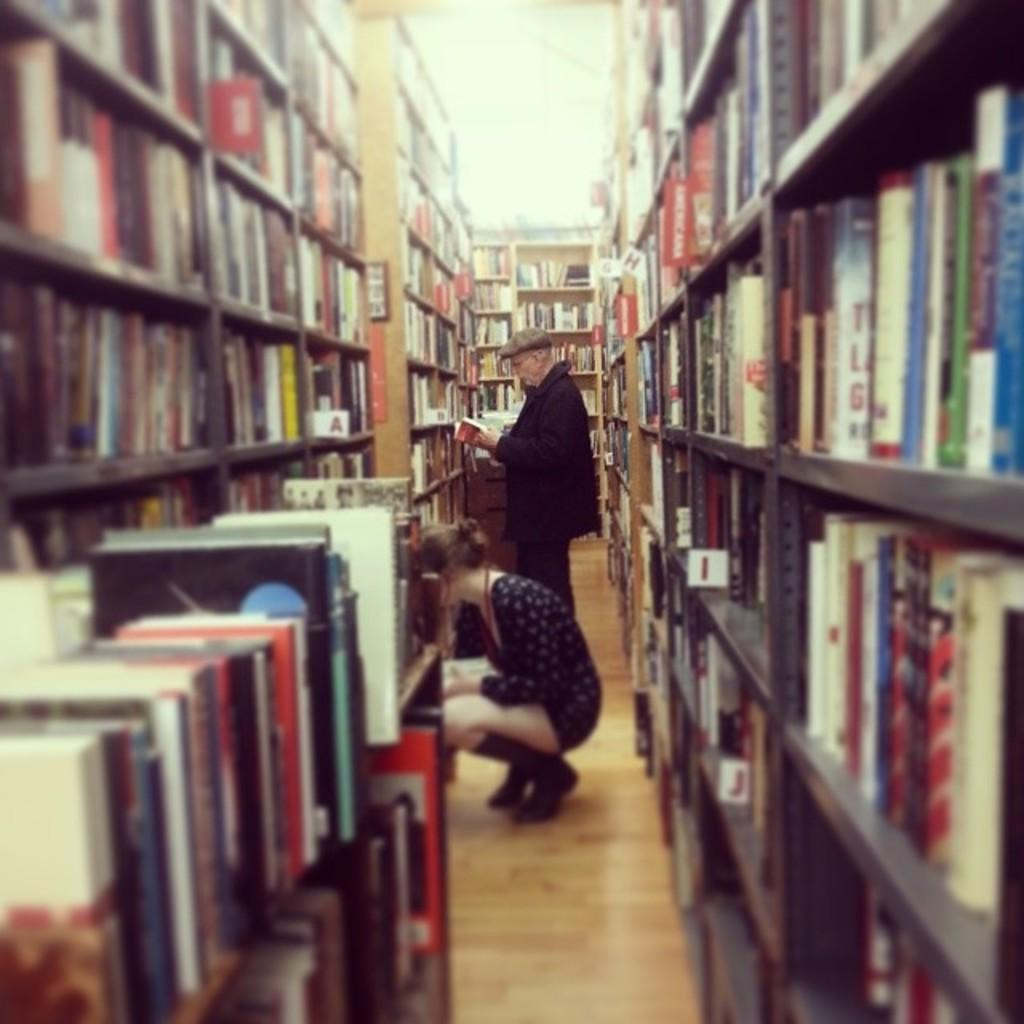<image>
Write a terse but informative summary of the picture. A man and a woman are in a row of shelves lined with books, with red lables identifying the subject, one of which is Americana. 